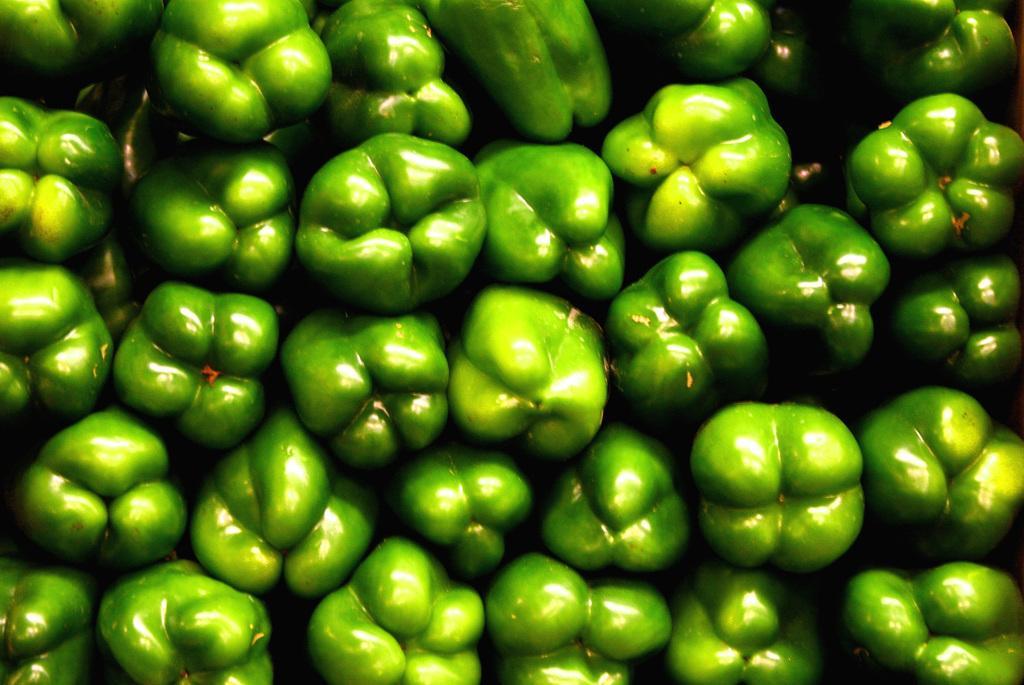How would you summarize this image in a sentence or two? In this image we can see the vegetables. 